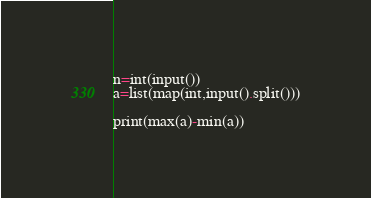<code> <loc_0><loc_0><loc_500><loc_500><_Python_>n=int(input())
a=list(map(int,input().split()))

print(max(a)-min(a))</code> 